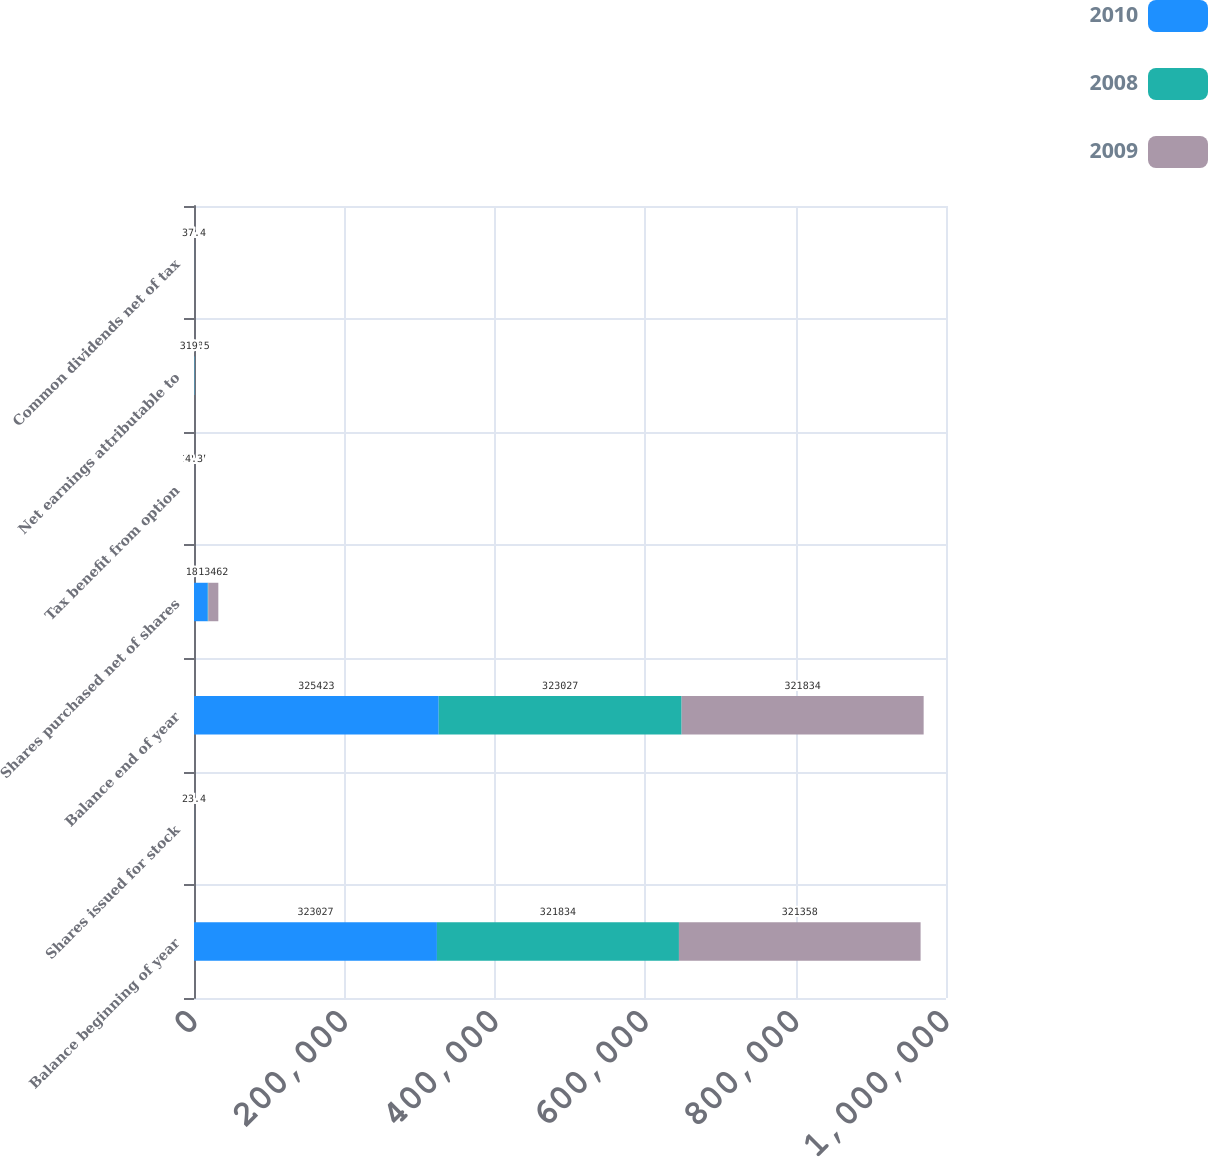Convert chart to OTSL. <chart><loc_0><loc_0><loc_500><loc_500><stacked_bar_chart><ecel><fcel>Balance beginning of year<fcel>Shares issued for stock<fcel>Balance end of year<fcel>Shares purchased net of shares<fcel>Tax benefit from option<fcel>Net earnings attributable to<fcel>Common dividends net of tax<nl><fcel>2010<fcel>323027<fcel>49.9<fcel>325423<fcel>18280<fcel>12.7<fcel>468<fcel>35.3<nl><fcel>2008<fcel>321834<fcel>37.3<fcel>323027<fcel>615<fcel>5.5<fcel>387.9<fcel>37.9<nl><fcel>2009<fcel>321358<fcel>23.4<fcel>321834<fcel>13462<fcel>4.3<fcel>319.5<fcel>37.4<nl></chart> 